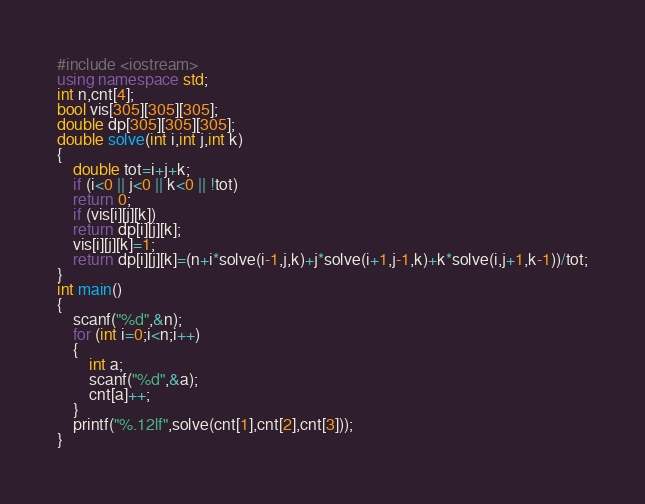<code> <loc_0><loc_0><loc_500><loc_500><_C++_>#include <iostream>
using namespace std;
int n,cnt[4];
bool vis[305][305][305];
double dp[305][305][305];
double solve(int i,int j,int k)
{
	double tot=i+j+k;
	if (i<0 || j<0 || k<0 || !tot)
	return 0;
	if (vis[i][j][k])
	return dp[i][j][k];
	vis[i][j][k]=1;
	return dp[i][j][k]=(n+i*solve(i-1,j,k)+j*solve(i+1,j-1,k)+k*solve(i,j+1,k-1))/tot;
}
int main()
{
	scanf("%d",&n);
	for (int i=0;i<n;i++)
	{
		int a;
		scanf("%d",&a);
		cnt[a]++;
	}
	printf("%.12lf",solve(cnt[1],cnt[2],cnt[3]));
}</code> 